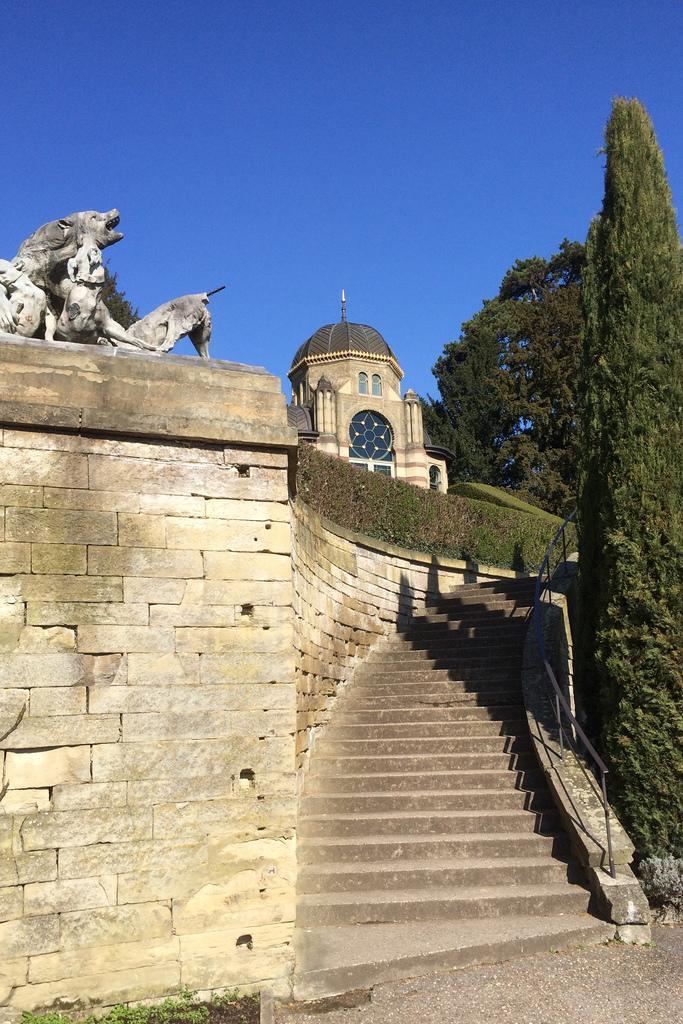In one or two sentences, can you explain what this image depicts? In the picture we can see a historical wall and on the top of it, we can see some dog sculptures and beside it, we can see the steps and on the top of the steps we can see the part of the palace and inside we can see the trees and in the background we can see the sky. 